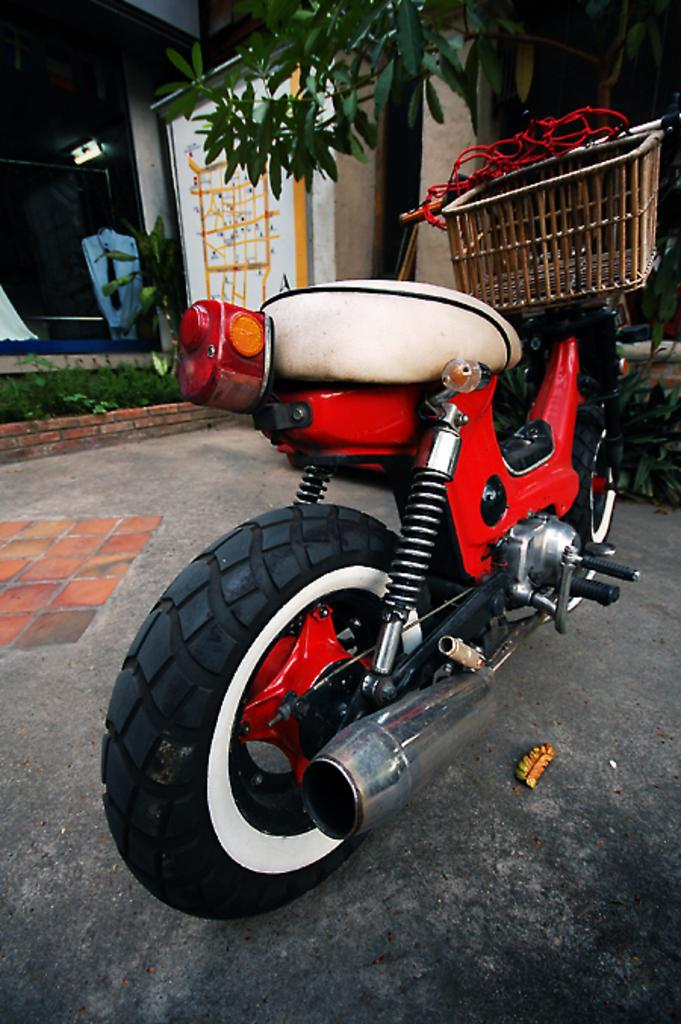What is the main subject of the image? There is a vehicle in the image. Where is the vehicle located? The vehicle is on the road. What can be seen in the background of the image? There is a house and a tree in the background of the image. What is the weight of the snake coiled around the tree in the image? There is no snake present in the image; it only features a vehicle on the road, a house, and a tree in the background. 